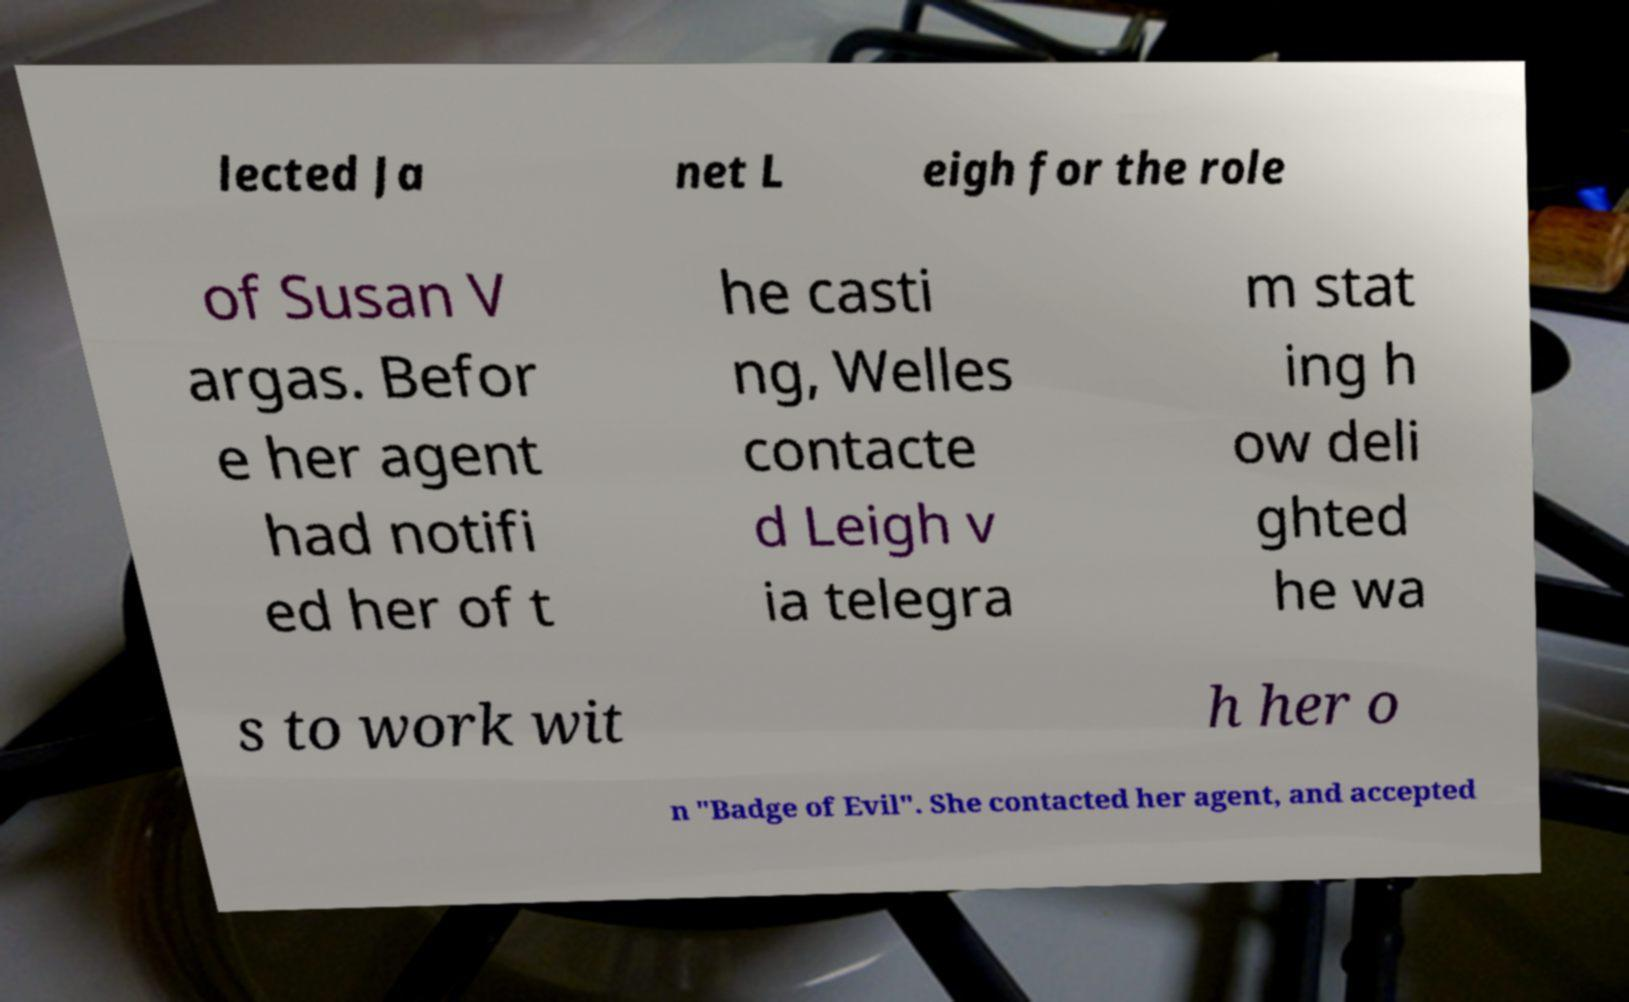I need the written content from this picture converted into text. Can you do that? lected Ja net L eigh for the role of Susan V argas. Befor e her agent had notifi ed her of t he casti ng, Welles contacte d Leigh v ia telegra m stat ing h ow deli ghted he wa s to work wit h her o n "Badge of Evil". She contacted her agent, and accepted 